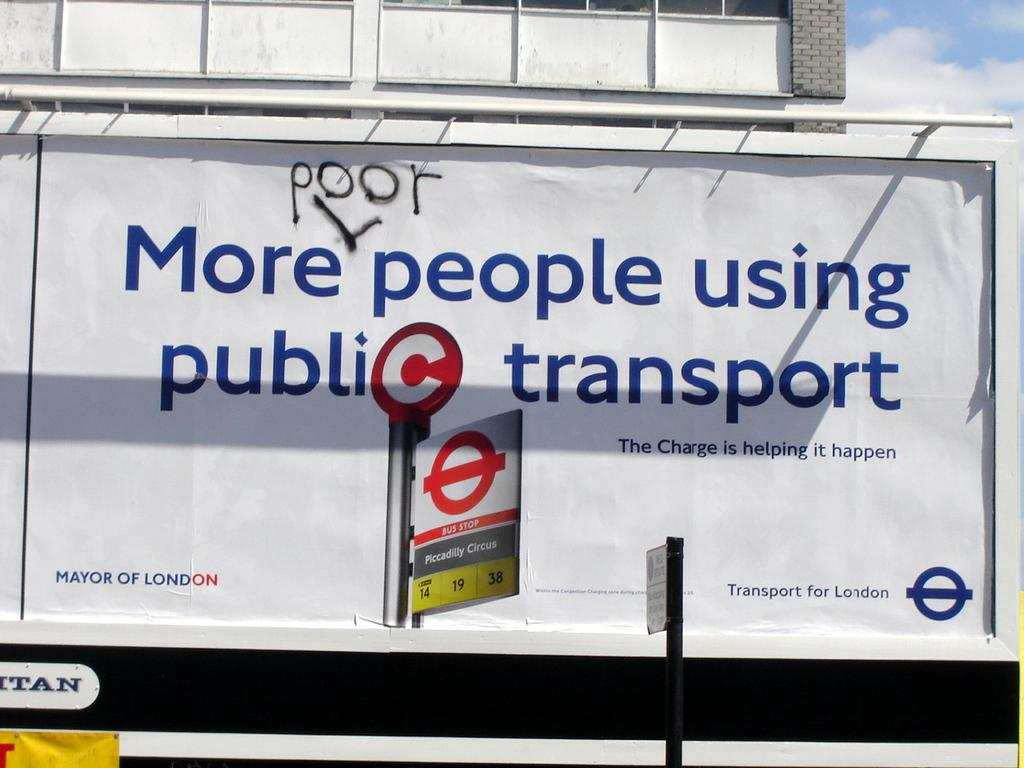<image>
Create a compact narrative representing the image presented. A sign advertising public transport, but someone has written the word "poor" over it. 